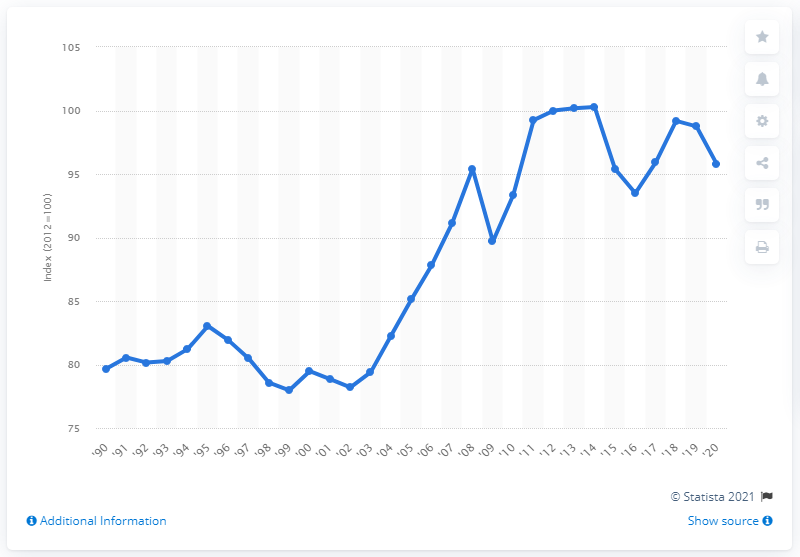Indicate a few pertinent items in this graphic. The Export Price Index for the United States in 2020 was 95.78. The Export Price Index for the previous year was 98.75. 